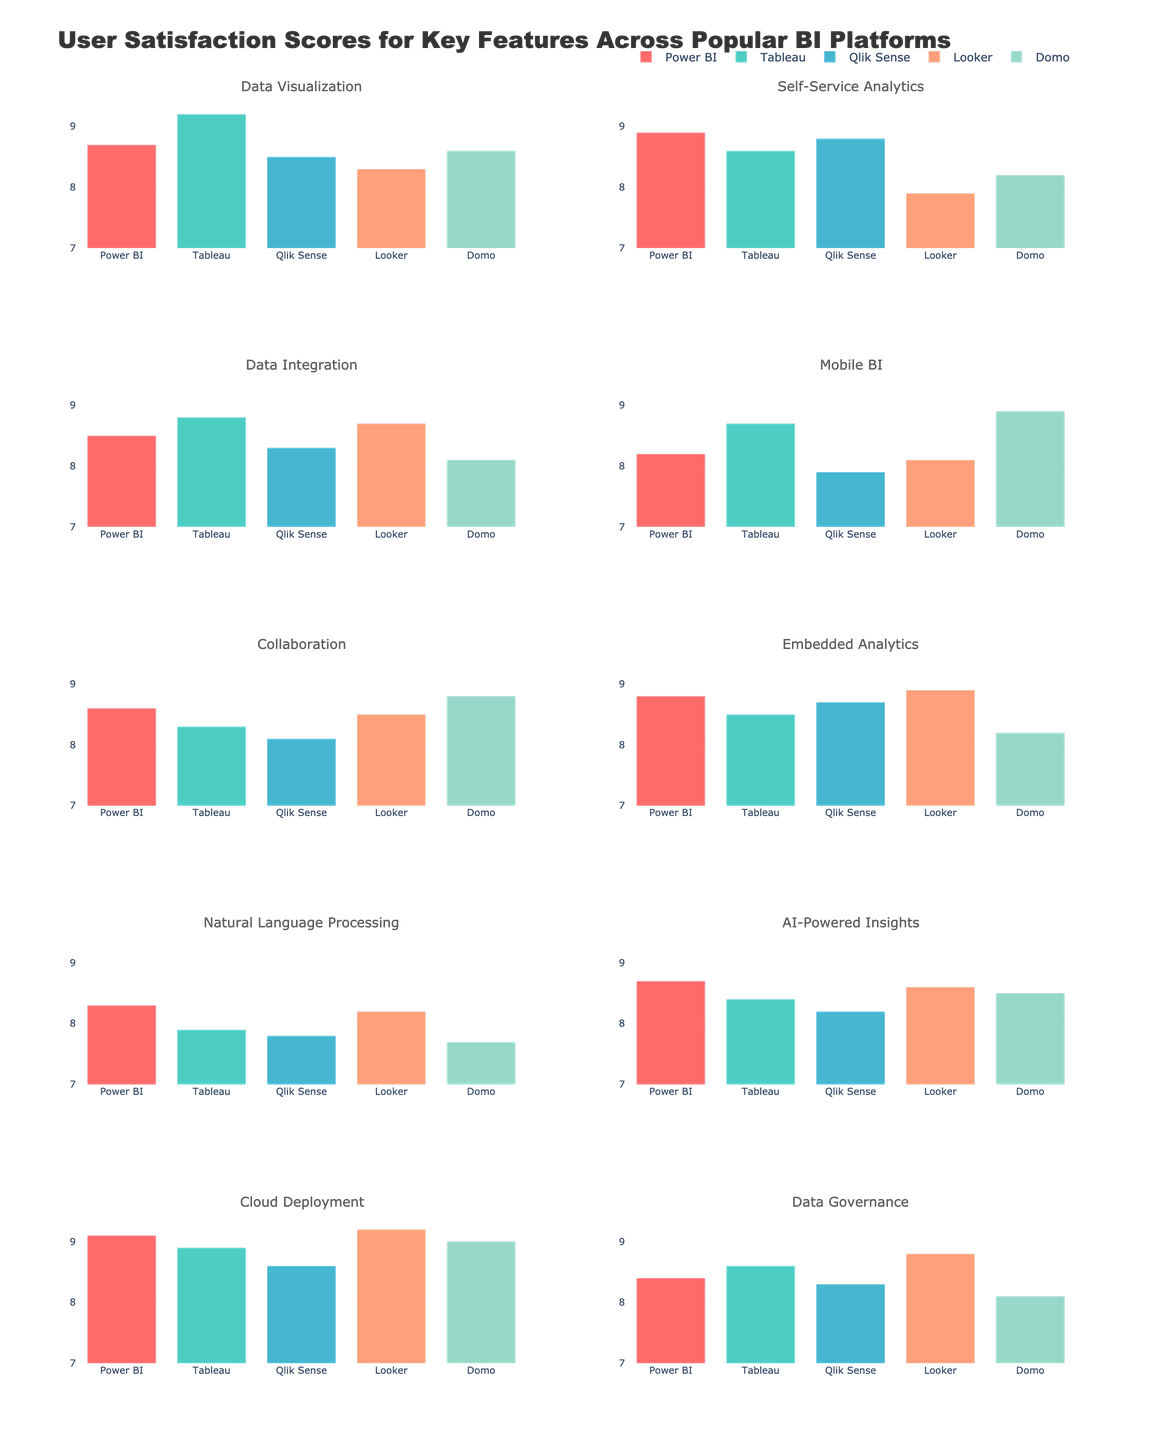Which BI platform has the highest user satisfaction score for data visualization? Look at the "Data Visualization" sub-plot and compare the bar heights. Tableau has the highest bar.
Answer: Tableau What is the average satisfaction score for Data Integration across all platforms? Add the scores for Data Integration (8.5 + 8.8 + 8.3 + 8.7 + 8.1) and divide by the number of platforms (5): (8.5 + 8.8 + 8.3 + 8.7 + 8.1) / 5 = 8.48
Answer: 8.48 Which feature has the largest variance in satisfaction scores across the platforms? Compare the ranges (max score - min score) of each feature's sub-plot. Data Visualization has a range of 9.2 (Tableau) - 8.3 (Looker) = 0.9, while Self-Service Analytics has a range of 8.9 (Power BI) - 7.9 (Looker) = 1.0, etc. The highest range is found in Self-Service Analytics.
Answer: Self-Service Analytics Which BI platform has the least satisfaction for Natural Language Processing? Look at the "Natural Language Processing" sub-plot and identify the shortest bar. Domo has the shortest bar.
Answer: Domo Is the satisfaction score for Mobile BI higher for Domo or Power BI? Compare the heights of the Mobile BI bars for Domo and Power BI. Domo's bar is higher.
Answer: Domo How much higher is the satisfaction score for Cloud Deployment in Looker compared to Tableau? Subtract Tableau's score from Looker's score for Cloud Deployment: 9.2 - 8.9 = 0.3
Answer: 0.3 Which feature has the most consistent satisfaction scores across all platforms (lowest variance)? Compare the ranges of each feature's satisfaction scores (max score - min score) across different features. Identify the feature with the smallest range. The Collaboration feature has a range of 8.8 - 8.1 = 0.7, which is the smallest.
Answer: Collaboration What is the difference in satisfaction scores for AI-Powered Insights between Power BI and Qlik Sense? Subtract Qlik Sense's score from Power BI's score for AI-Powered Insights: 8.7 - 8.2 = 0.5
Answer: 0.5 